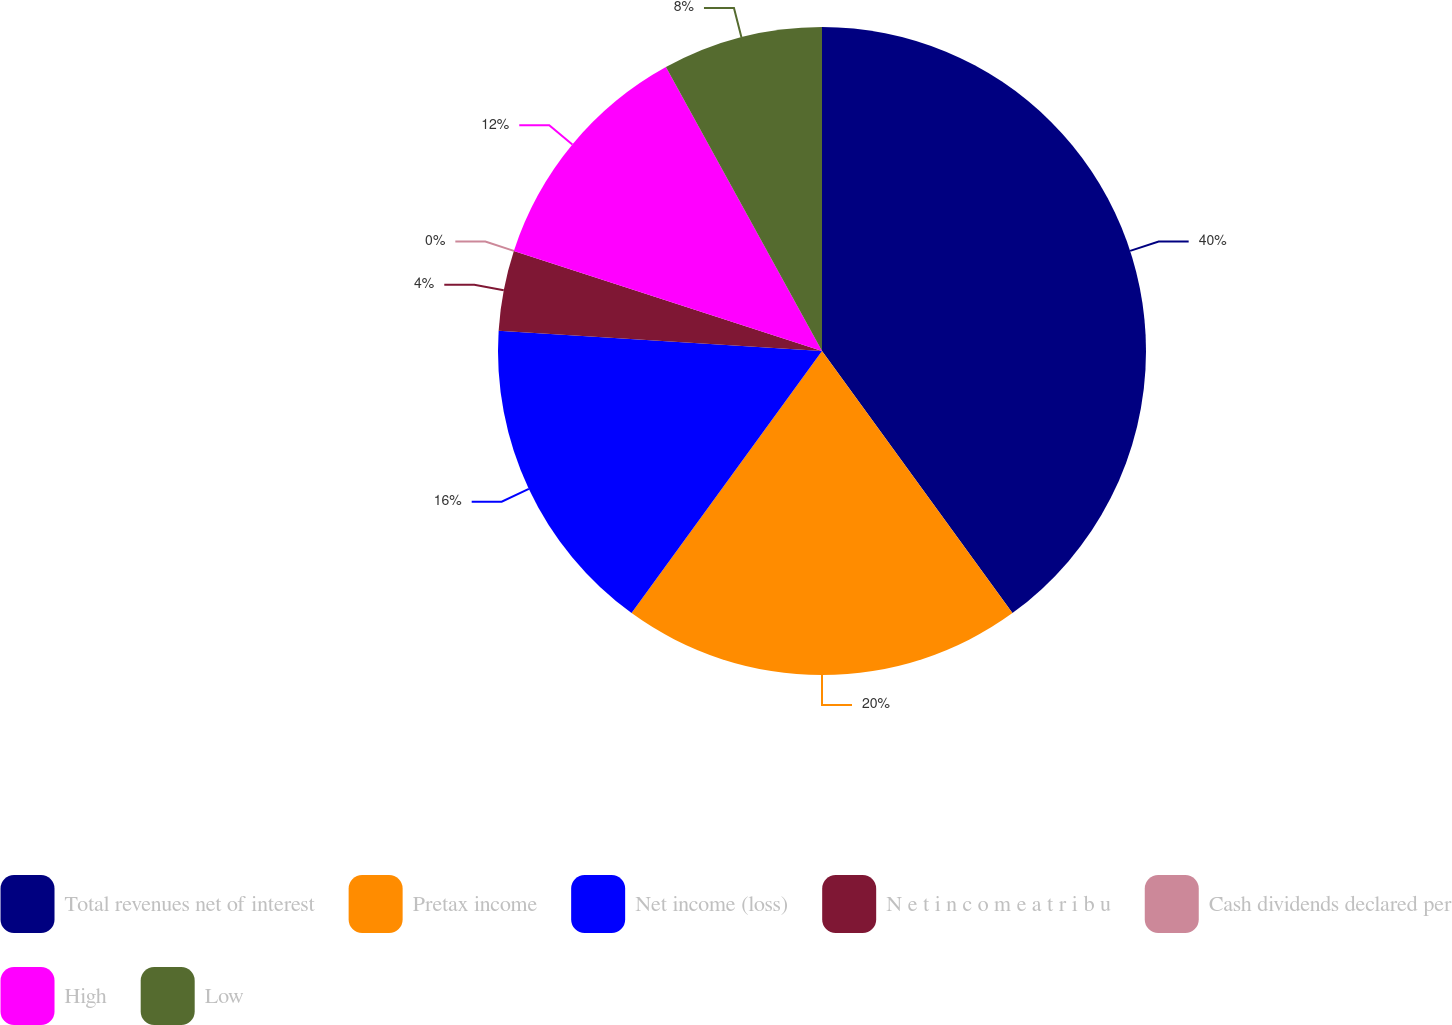Convert chart. <chart><loc_0><loc_0><loc_500><loc_500><pie_chart><fcel>Total revenues net of interest<fcel>Pretax income<fcel>Net income (loss)<fcel>N e t i n c o m e a t r i b u<fcel>Cash dividends declared per<fcel>High<fcel>Low<nl><fcel>40.0%<fcel>20.0%<fcel>16.0%<fcel>4.0%<fcel>0.0%<fcel>12.0%<fcel>8.0%<nl></chart> 